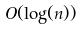<formula> <loc_0><loc_0><loc_500><loc_500>O ( \log ( n ) )</formula> 